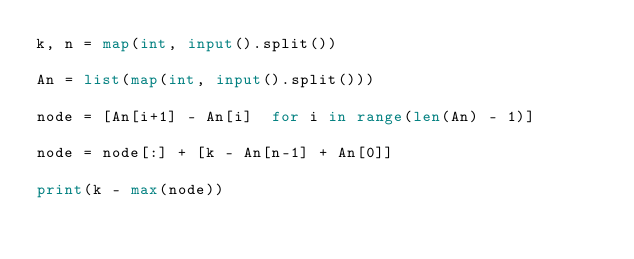<code> <loc_0><loc_0><loc_500><loc_500><_Python_>k, n = map(int, input().split())
 
An = list(map(int, input().split()))
 
node = [An[i+1] - An[i]  for i in range(len(An) - 1)]
 
node = node[:] + [k - An[n-1] + An[0]]
 
print(k - max(node))</code> 